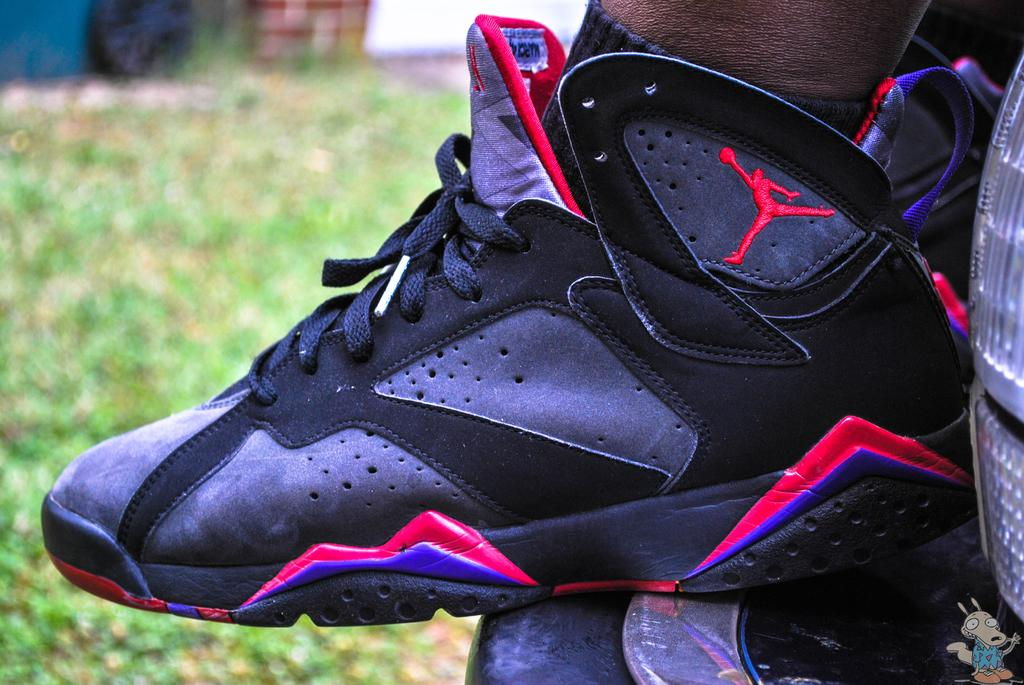What can be seen in the image? There is a shoe in the image. Can you describe the object located in the bottom right of the image? Unfortunately, the provided facts do not give any information about the object in the bottom right of the image. What is the appearance of the background in the image? The background of the image is blurred. What type of horn can be seen on the edge of the shoe in the image? There is no horn or edge present on the shoe in the image. 